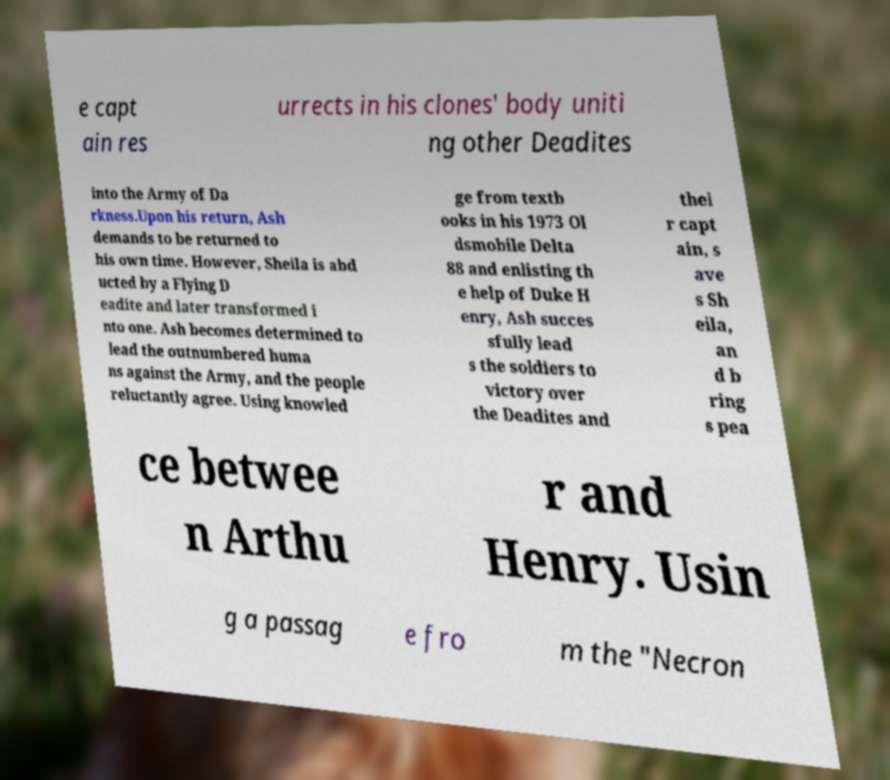What messages or text are displayed in this image? I need them in a readable, typed format. e capt ain res urrects in his clones' body uniti ng other Deadites into the Army of Da rkness.Upon his return, Ash demands to be returned to his own time. However, Sheila is abd ucted by a Flying D eadite and later transformed i nto one. Ash becomes determined to lead the outnumbered huma ns against the Army, and the people reluctantly agree. Using knowled ge from textb ooks in his 1973 Ol dsmobile Delta 88 and enlisting th e help of Duke H enry, Ash succes sfully lead s the soldiers to victory over the Deadites and thei r capt ain, s ave s Sh eila, an d b ring s pea ce betwee n Arthu r and Henry. Usin g a passag e fro m the "Necron 